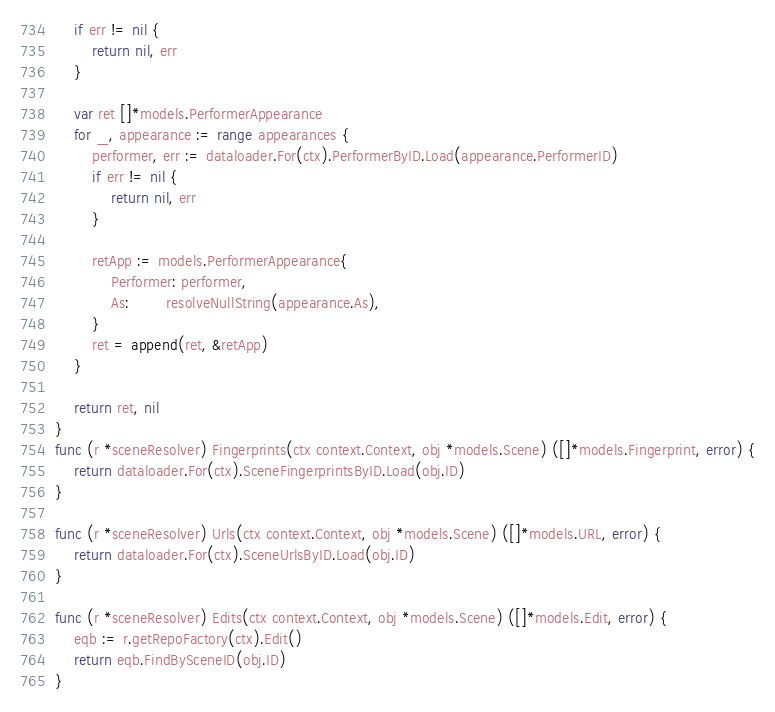<code> <loc_0><loc_0><loc_500><loc_500><_Go_>	if err != nil {
		return nil, err
	}

	var ret []*models.PerformerAppearance
	for _, appearance := range appearances {
		performer, err := dataloader.For(ctx).PerformerByID.Load(appearance.PerformerID)
		if err != nil {
			return nil, err
		}

		retApp := models.PerformerAppearance{
			Performer: performer,
			As:        resolveNullString(appearance.As),
		}
		ret = append(ret, &retApp)
	}

	return ret, nil
}
func (r *sceneResolver) Fingerprints(ctx context.Context, obj *models.Scene) ([]*models.Fingerprint, error) {
	return dataloader.For(ctx).SceneFingerprintsByID.Load(obj.ID)
}

func (r *sceneResolver) Urls(ctx context.Context, obj *models.Scene) ([]*models.URL, error) {
	return dataloader.For(ctx).SceneUrlsByID.Load(obj.ID)
}

func (r *sceneResolver) Edits(ctx context.Context, obj *models.Scene) ([]*models.Edit, error) {
	eqb := r.getRepoFactory(ctx).Edit()
	return eqb.FindBySceneID(obj.ID)
}
</code> 